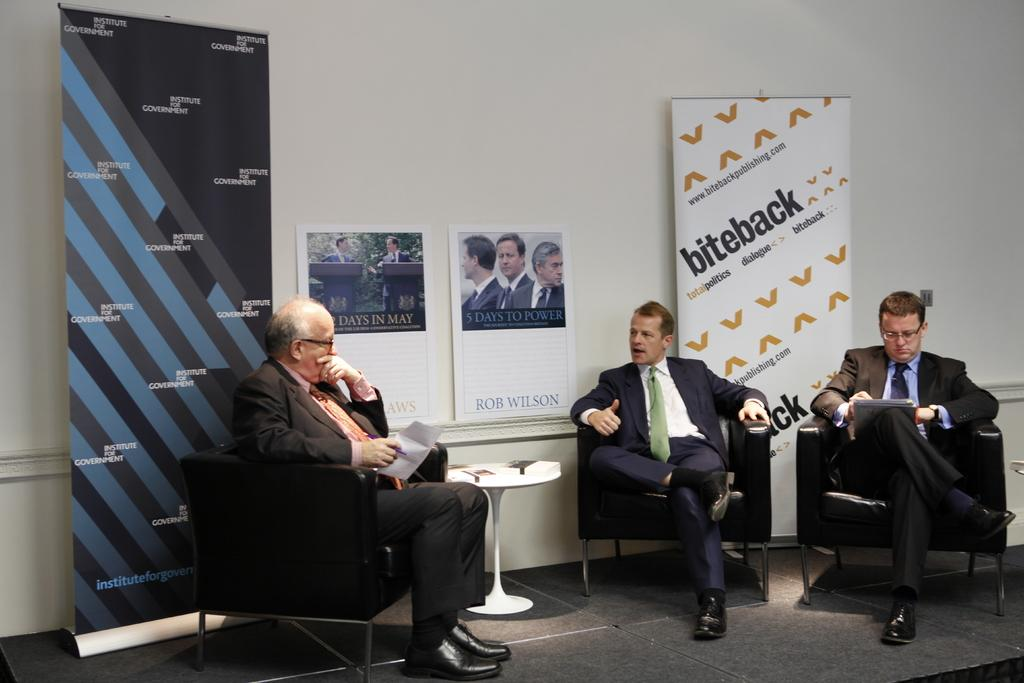How many people are in the image? There are three men in the image. What are the men doing in the image? The men are sitting on a chair. Where is the chair located in relation to the table? The chair is in front of a table. What is the table resting on? The table is on the floor. What type of insect can be seen flying around the men in the image? There are no insects visible in the image; it only features three men sitting on a chair in front of a table. 